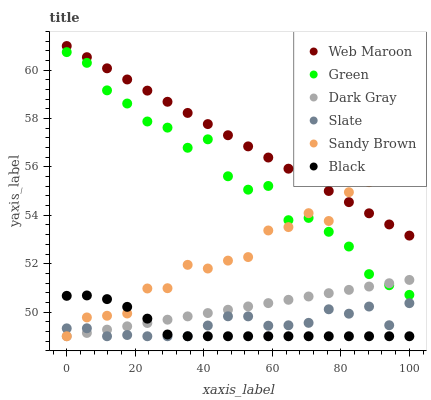Does Black have the minimum area under the curve?
Answer yes or no. Yes. Does Web Maroon have the maximum area under the curve?
Answer yes or no. Yes. Does Dark Gray have the minimum area under the curve?
Answer yes or no. No. Does Dark Gray have the maximum area under the curve?
Answer yes or no. No. Is Dark Gray the smoothest?
Answer yes or no. Yes. Is Green the roughest?
Answer yes or no. Yes. Is Web Maroon the smoothest?
Answer yes or no. No. Is Web Maroon the roughest?
Answer yes or no. No. Does Slate have the lowest value?
Answer yes or no. Yes. Does Web Maroon have the lowest value?
Answer yes or no. No. Does Web Maroon have the highest value?
Answer yes or no. Yes. Does Dark Gray have the highest value?
Answer yes or no. No. Is Black less than Web Maroon?
Answer yes or no. Yes. Is Green greater than Black?
Answer yes or no. Yes. Does Dark Gray intersect Sandy Brown?
Answer yes or no. Yes. Is Dark Gray less than Sandy Brown?
Answer yes or no. No. Is Dark Gray greater than Sandy Brown?
Answer yes or no. No. Does Black intersect Web Maroon?
Answer yes or no. No. 